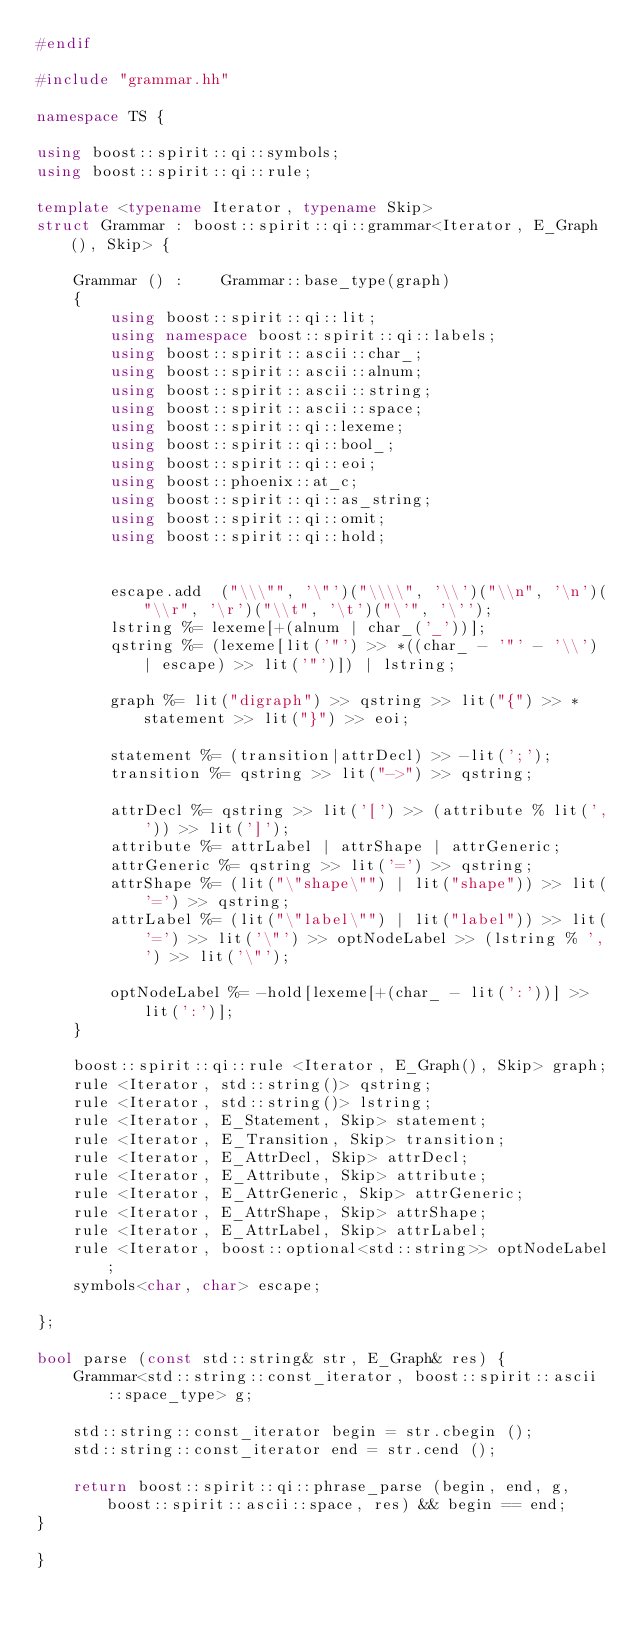<code> <loc_0><loc_0><loc_500><loc_500><_C++_>#endif

#include "grammar.hh"

namespace TS {

using boost::spirit::qi::symbols;
using boost::spirit::qi::rule;

template <typename Iterator, typename Skip>
struct Grammar : boost::spirit::qi::grammar<Iterator, E_Graph(), Skip> {

	Grammar () :	Grammar::base_type(graph)
	{
		using boost::spirit::qi::lit;
		using namespace boost::spirit::qi::labels;
		using boost::spirit::ascii::char_;
		using boost::spirit::ascii::alnum;
		using boost::spirit::ascii::string;
		using boost::spirit::ascii::space;
		using boost::spirit::qi::lexeme;
		using boost::spirit::qi::bool_;
		using boost::spirit::qi::eoi;
		using boost::phoenix::at_c;
		using boost::spirit::qi::as_string;
		using boost::spirit::qi::omit;
		using boost::spirit::qi::hold;


		escape.add	("\\\"", '\"')("\\\\", '\\')("\\n", '\n')("\\r", '\r')("\\t", '\t')("\'", '\'');
		lstring %= lexeme[+(alnum | char_('_'))];
		qstring %= (lexeme[lit('"') >> *((char_ - '"' - '\\') | escape) >> lit('"')]) | lstring;

		graph %= lit("digraph") >> qstring >> lit("{") >> *statement >> lit("}") >> eoi;

		statement %= (transition|attrDecl) >> -lit(';');
		transition %= qstring >> lit("->") >> qstring;

		attrDecl %= qstring >> lit('[') >> (attribute % lit(',')) >> lit(']');
		attribute %= attrLabel | attrShape | attrGeneric;
		attrGeneric %= qstring >> lit('=') >> qstring;
		attrShape %= (lit("\"shape\"") | lit("shape")) >> lit('=') >> qstring;
		attrLabel %= (lit("\"label\"") | lit("label")) >> lit('=') >> lit('\"') >> optNodeLabel >> (lstring % ',') >> lit('\"');

		optNodeLabel %= -hold[lexeme[+(char_ - lit(':'))] >> lit(':')];
	}

	boost::spirit::qi::rule <Iterator, E_Graph(), Skip> graph;
	rule <Iterator, std::string()> qstring;
	rule <Iterator, std::string()> lstring;
	rule <Iterator, E_Statement, Skip> statement;
	rule <Iterator, E_Transition, Skip> transition;
	rule <Iterator, E_AttrDecl, Skip> attrDecl;
	rule <Iterator, E_Attribute, Skip> attribute;
	rule <Iterator, E_AttrGeneric, Skip> attrGeneric;
	rule <Iterator, E_AttrShape, Skip> attrShape;
	rule <Iterator, E_AttrLabel, Skip> attrLabel;
	rule <Iterator, boost::optional<std::string>> optNodeLabel;
	symbols<char, char> escape;

};

bool parse (const std::string& str, E_Graph& res) {
	Grammar<std::string::const_iterator, boost::spirit::ascii::space_type> g;

	std::string::const_iterator begin = str.cbegin ();
	std::string::const_iterator end = str.cend ();

	return boost::spirit::qi::phrase_parse (begin, end, g, boost::spirit::ascii::space, res) && begin == end;
}

}
</code> 